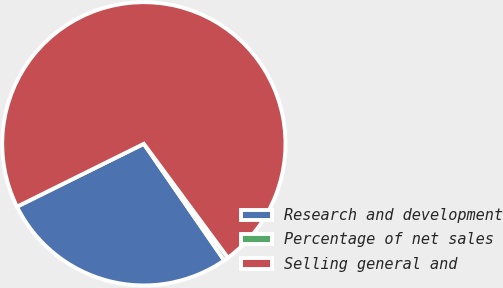Convert chart to OTSL. <chart><loc_0><loc_0><loc_500><loc_500><pie_chart><fcel>Research and development<fcel>Percentage of net sales<fcel>Selling general and<nl><fcel>27.28%<fcel>0.51%<fcel>72.21%<nl></chart> 